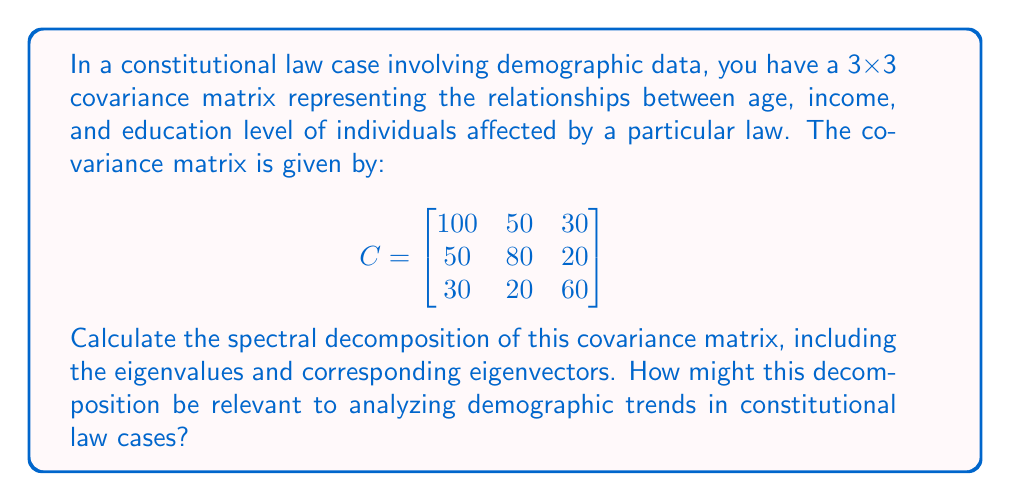Could you help me with this problem? To calculate the spectral decomposition of the covariance matrix, we need to find its eigenvalues and eigenvectors. The steps are as follows:

1. Find the characteristic equation:
   $det(C - \lambda I) = 0$

2. Solve for eigenvalues:
   $\begin{vmatrix}
   100-\lambda & 50 & 30 \\
   50 & 80-\lambda & 20 \\
   30 & 20 & 60-\lambda
   \end{vmatrix} = 0$

   This yields the equation:
   $-\lambda^3 + 240\lambda^2 - 17100\lambda + 360000 = 0$

3. Solve this cubic equation to get the eigenvalues:
   $\lambda_1 \approx 153.20$, $\lambda_2 \approx 67.91$, $\lambda_3 \approx 18.89$

4. For each eigenvalue, find the corresponding eigenvector by solving:
   $(C - \lambda_i I)v_i = 0$

5. Normalize each eigenvector to unit length.

After calculations, we get the following normalized eigenvectors:

$v_1 \approx \begin{bmatrix} 0.710 \\ 0.628 \\ 0.319 \end{bmatrix}$

$v_2 \approx \begin{bmatrix} -0.516 \\ 0.295 \\ 0.805 \end{bmatrix}$

$v_3 \approx \begin{bmatrix} 0.479 \\ -0.720 \\ 0.502 \end{bmatrix}$

The spectral decomposition is then given by:

$C = V\Lambda V^T$

Where $V = [v_1 \; v_2 \; v_3]$ and $\Lambda = diag(\lambda_1, \lambda_2, \lambda_3)$

This decomposition is relevant to constitutional law cases as it helps identify the principal components of demographic variation. The largest eigenvalue and its corresponding eigenvector represent the most significant demographic trend, which could be crucial in understanding the impact of laws on different population segments.
Answer: Eigenvalues: $\lambda_1 \approx 153.20$, $\lambda_2 \approx 67.91$, $\lambda_3 \approx 18.89$
Eigenvectors:
$v_1 \approx [0.710, 0.628, 0.319]^T$
$v_2 \approx [-0.516, 0.295, 0.805]^T$
$v_3 \approx [0.479, -0.720, 0.502]^T$ 